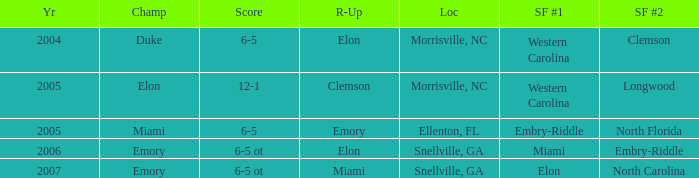How many teams were listed as runner up in 2005 and there the first semi finalist was Western Carolina? 1.0. 